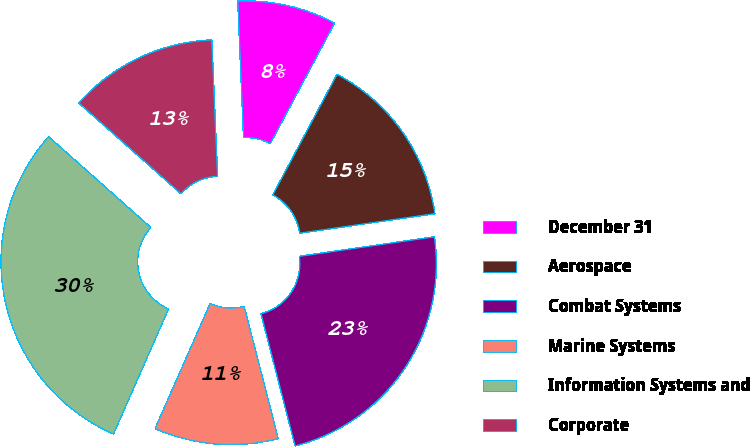Convert chart to OTSL. <chart><loc_0><loc_0><loc_500><loc_500><pie_chart><fcel>December 31<fcel>Aerospace<fcel>Combat Systems<fcel>Marine Systems<fcel>Information Systems and<fcel>Corporate<nl><fcel>8.47%<fcel>14.92%<fcel>23.27%<fcel>10.62%<fcel>29.96%<fcel>12.77%<nl></chart> 